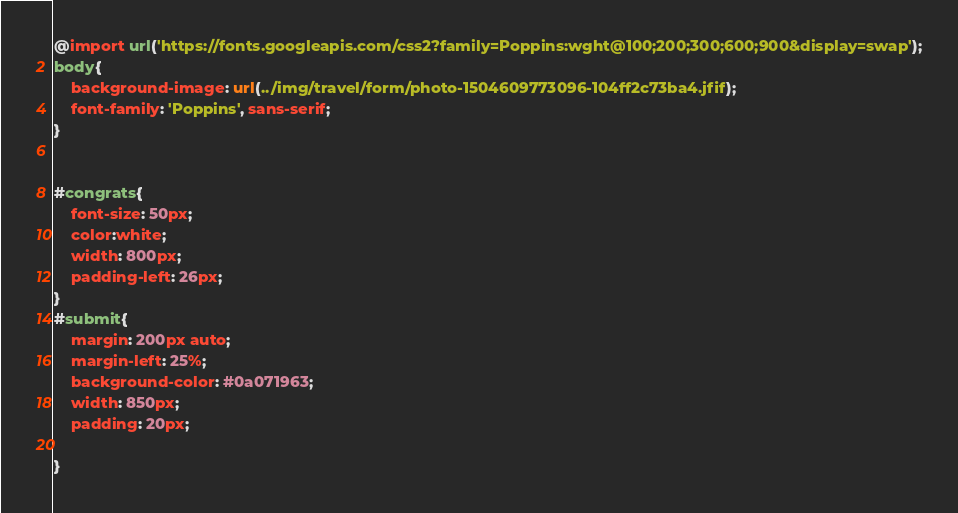Convert code to text. <code><loc_0><loc_0><loc_500><loc_500><_CSS_>@import url('https://fonts.googleapis.com/css2?family=Poppins:wght@100;200;300;600;900&display=swap');
body{
    background-image: url(../img/travel/form/photo-1504609773096-104ff2c73ba4.jfif);
    font-family: 'Poppins', sans-serif;
}


#congrats{
    font-size: 50px;
    color:white;
    width: 800px;
    padding-left: 26px;
}
#submit{
    margin: 200px auto;
    margin-left: 25%;
    background-color: #0a071963;
    width: 850px;
    padding: 20px;
    
}
</code> 